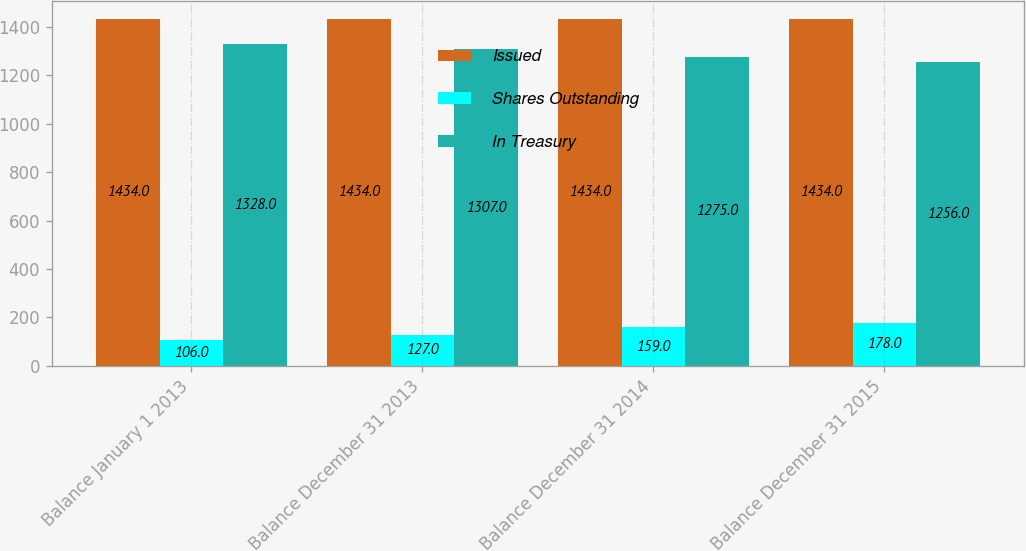Convert chart. <chart><loc_0><loc_0><loc_500><loc_500><stacked_bar_chart><ecel><fcel>Balance January 1 2013<fcel>Balance December 31 2013<fcel>Balance December 31 2014<fcel>Balance December 31 2015<nl><fcel>Issued<fcel>1434<fcel>1434<fcel>1434<fcel>1434<nl><fcel>Shares Outstanding<fcel>106<fcel>127<fcel>159<fcel>178<nl><fcel>In Treasury<fcel>1328<fcel>1307<fcel>1275<fcel>1256<nl></chart> 